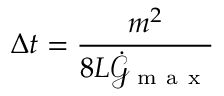<formula> <loc_0><loc_0><loc_500><loc_500>\Delta t = \frac { m ^ { 2 } } { 8 L \dot { \mathcal { G } } _ { m a x } }</formula> 